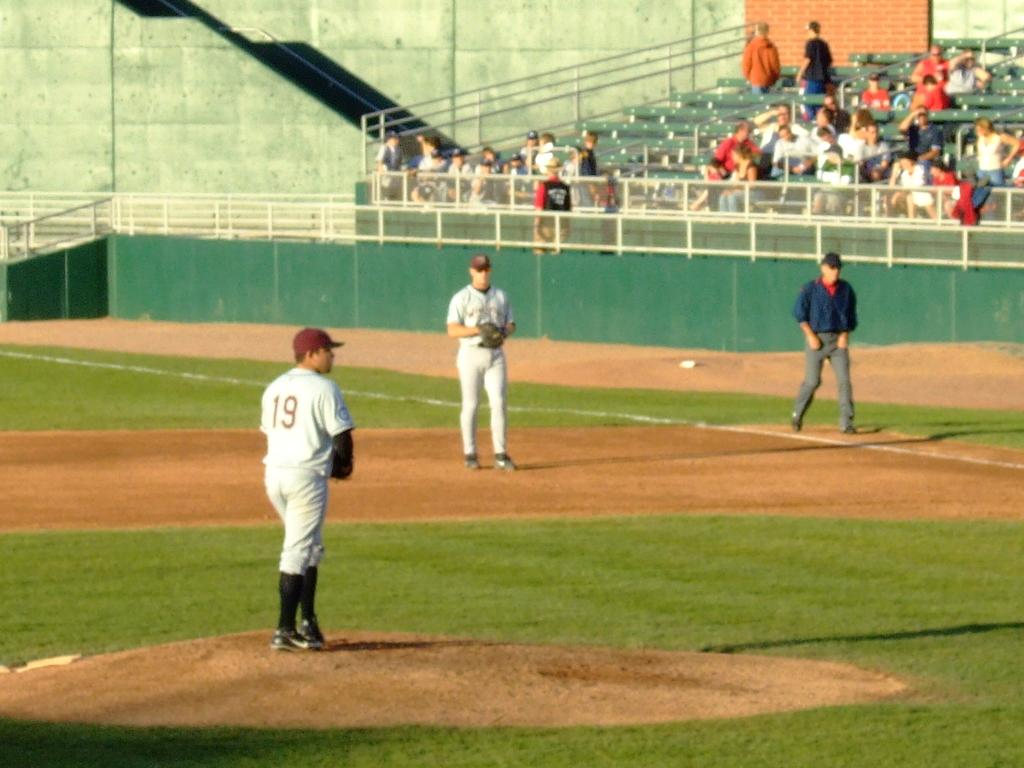<image>
Create a compact narrative representing the image presented. Pitcher number 19 on the mound during a baseball game. 